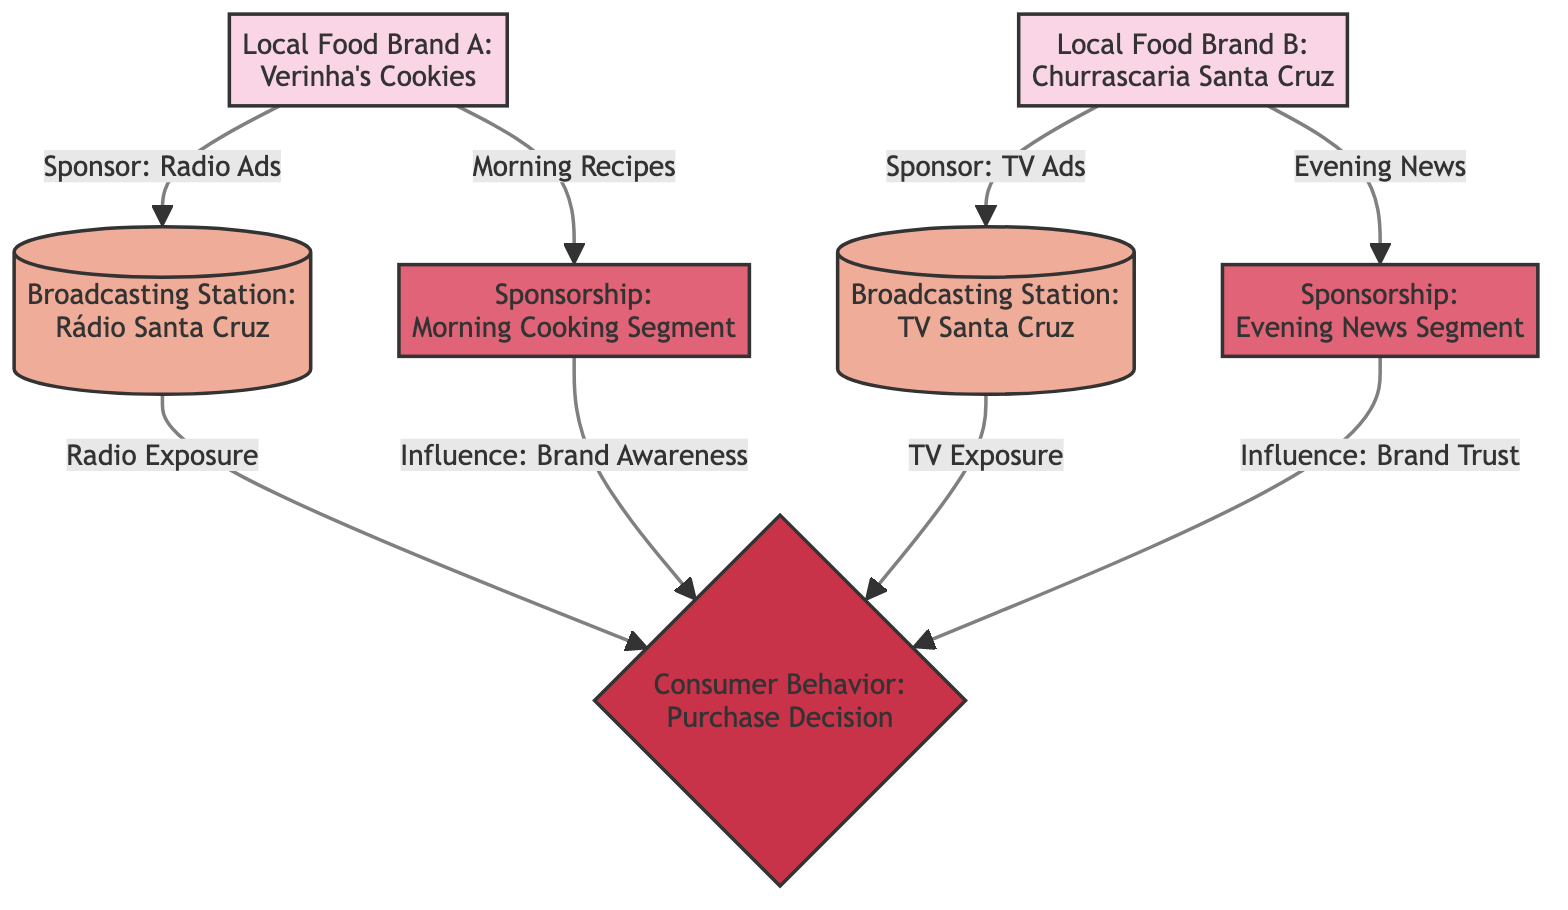What is the first local food brand mentioned in the diagram? The diagram lists "Local Food Brand A: Verinha's Cookies" as the first brand.
Answer: Verinha's Cookies How many broadcasting stations are represented in the diagram? There are two broadcasting stations shown: Rádio Santa Cruz and TV Santa Cruz.
Answer: 2 Which local food brand sponsors the morning cooking segment? The diagram indicates that "Local Food Brand A: Verinha's Cookies" is the sponsor of the morning cooking segment.
Answer: Verinha's Cookies What type of advertisement does Churrascaria Santa Cruz use? The diagram shows that Churrascaria Santa Cruz uses TV ads as their mode of advertisement.
Answer: TV Ads What influences brand awareness according to the diagram? The diagram indicates that the "Morning Cooking Segment" influences brand awareness.
Answer: Morning Cooking Segment Which consumer behavior is influenced by both sponsorships? The diagram shows that both sponsorships influence "Consumer Behavior: Purchase Decision."
Answer: Purchase Decision What is the relationship between Rádio Santa Cruz and consumer behavior? The diagram illustrates that Rádio Santa Cruz influences consumer behavior through radio exposure.
Answer: Radio Exposure How many sponsorship nodes are present in the diagram? There are two sponsorship nodes: one for the morning cooking segment and one for the evening news segment.
Answer: 2 Which broadcasting station is associated with Churrascaria Santa Cruz? The diagram connects Churrascaria Santa Cruz to the broadcasting station TV Santa Cruz.
Answer: TV Santa Cruz 